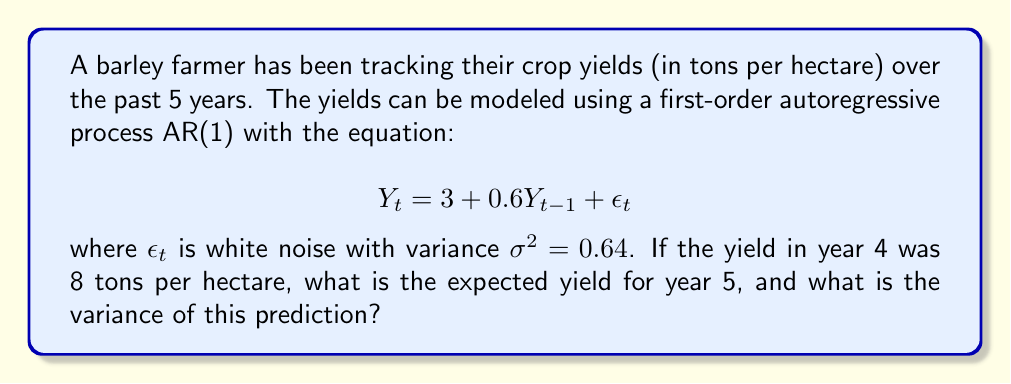What is the answer to this math problem? To solve this problem, we'll follow these steps:

1. Calculate the expected yield for year 5:
   The AR(1) process is given by $Y_t = 3 + 0.6Y_{t-1} + \epsilon_t$
   We know that $Y_4 = 8$ tons per hectare
   
   Expected value of $Y_5$:
   $$E[Y_5] = 3 + 0.6E[Y_4] = 3 + 0.6(8) = 3 + 4.8 = 7.8$$

2. Calculate the variance of the prediction:
   For an AR(1) process, the variance of the prediction is equal to the variance of the white noise term $\epsilon_t$
   
   $$Var(Y_5) = \sigma^2 = 0.64$$

Therefore, the expected yield for year 5 is 7.8 tons per hectare, and the variance of this prediction is 0.64.
Answer: Expected yield: 7.8 tons/ha; Variance: 0.64 